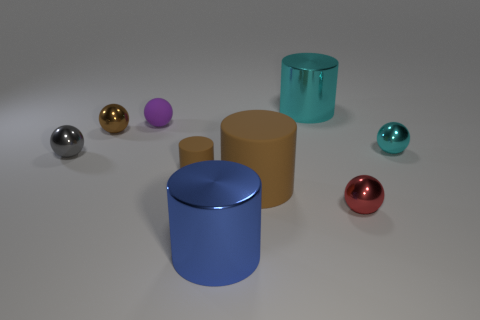Is the number of small gray spheres right of the big brown thing less than the number of large blue metallic things?
Provide a short and direct response. Yes. What number of small cylinders are the same color as the tiny matte ball?
Give a very brief answer. 0. Are there fewer shiny spheres than tiny purple matte spheres?
Provide a succinct answer. No. Are the small gray thing and the small brown ball made of the same material?
Provide a succinct answer. Yes. What number of other things are there of the same size as the blue metallic thing?
Offer a terse response. 2. What color is the matte thing behind the small rubber thing that is in front of the gray thing?
Provide a succinct answer. Purple. How many other things are the same shape as the red thing?
Give a very brief answer. 4. Is there a tiny blue thing that has the same material as the red ball?
Keep it short and to the point. No. There is a gray thing that is the same size as the brown ball; what material is it?
Offer a very short reply. Metal. What is the color of the large thing that is behind the metal ball that is behind the cyan metal thing that is in front of the tiny purple matte object?
Your answer should be compact. Cyan. 